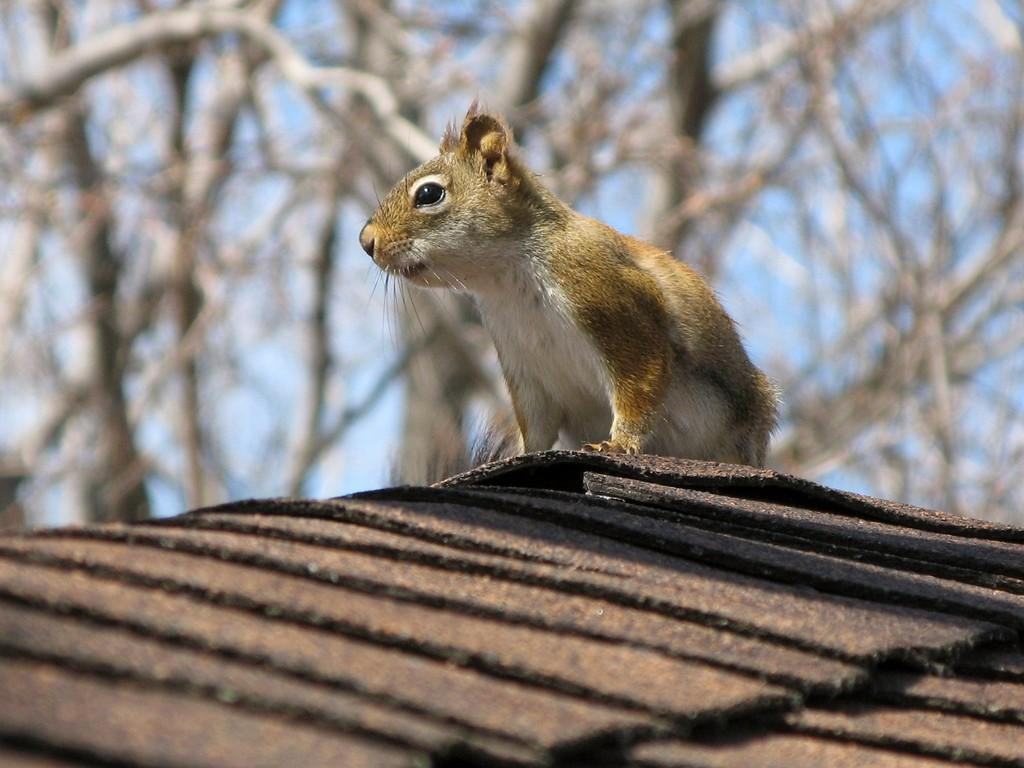What type of living creature is in the image? There is an animal in the image. What else can be seen in the image besides the animal? There are objects in the image. What can be seen in the background of the image? There are trees and the sky visible in the background of the image. How would you describe the appearance of the image? The image has a blurry appearance. What discovery did the animal's grandfather make in the image? There is no mention of a grandfather or any discovery in the image; it only features an animal, objects, trees, the sky, and a blurry appearance. 